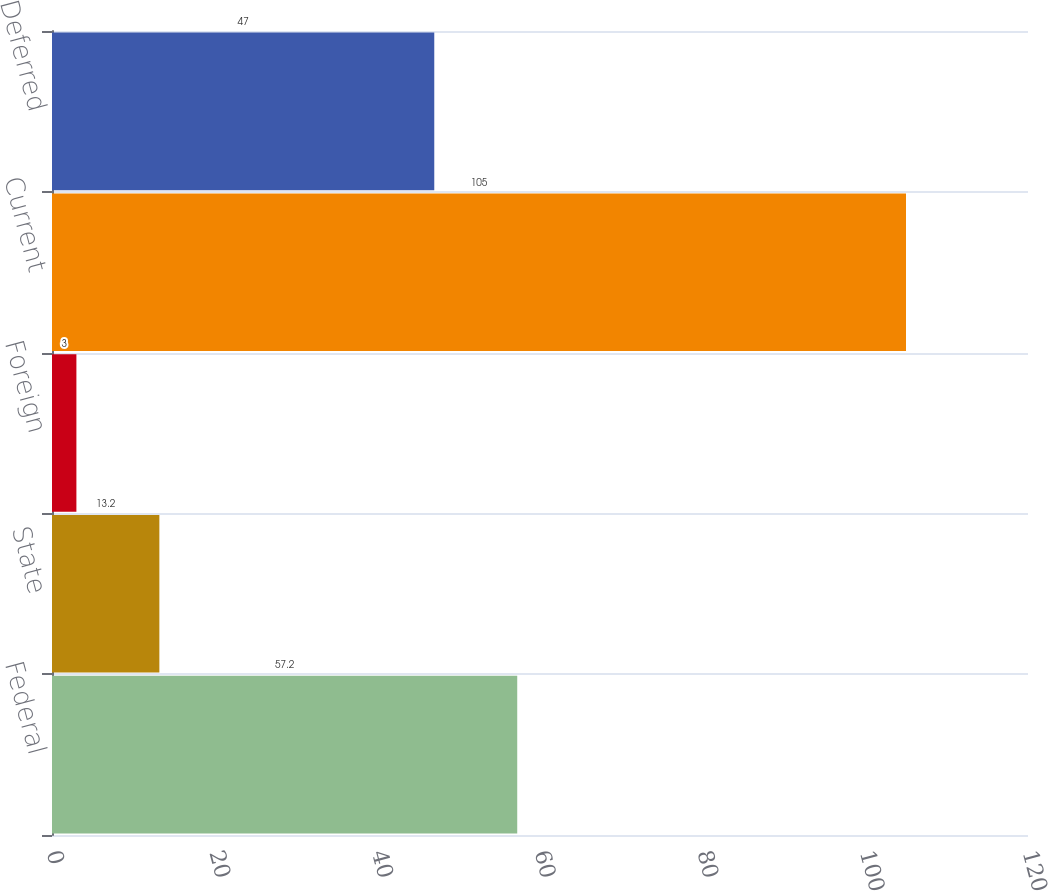Convert chart. <chart><loc_0><loc_0><loc_500><loc_500><bar_chart><fcel>Federal<fcel>State<fcel>Foreign<fcel>Current<fcel>Deferred<nl><fcel>57.2<fcel>13.2<fcel>3<fcel>105<fcel>47<nl></chart> 